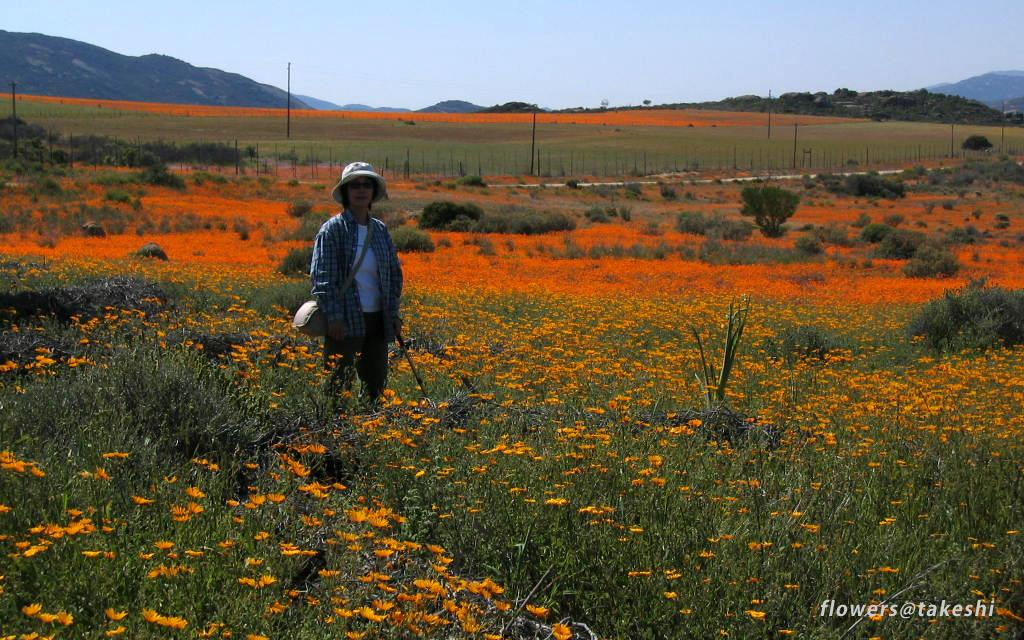What is the main subject of the image? There is a person standing in the image. What is the person holding in the image? The person is holding a stick. What type of vegetation can be seen in the image? There are plants with flowers in the image. What structures are present in the image? There are poles in the image. What natural features can be seen in the image? There are mountains in the image. What is visible in the background of the image? The sky is visible in the image. What type of jewel is the person wearing in the image? There is no mention of a jewel in the image; the person is holding a stick and standing near plants with flowers, poles, mountains, and the sky. 